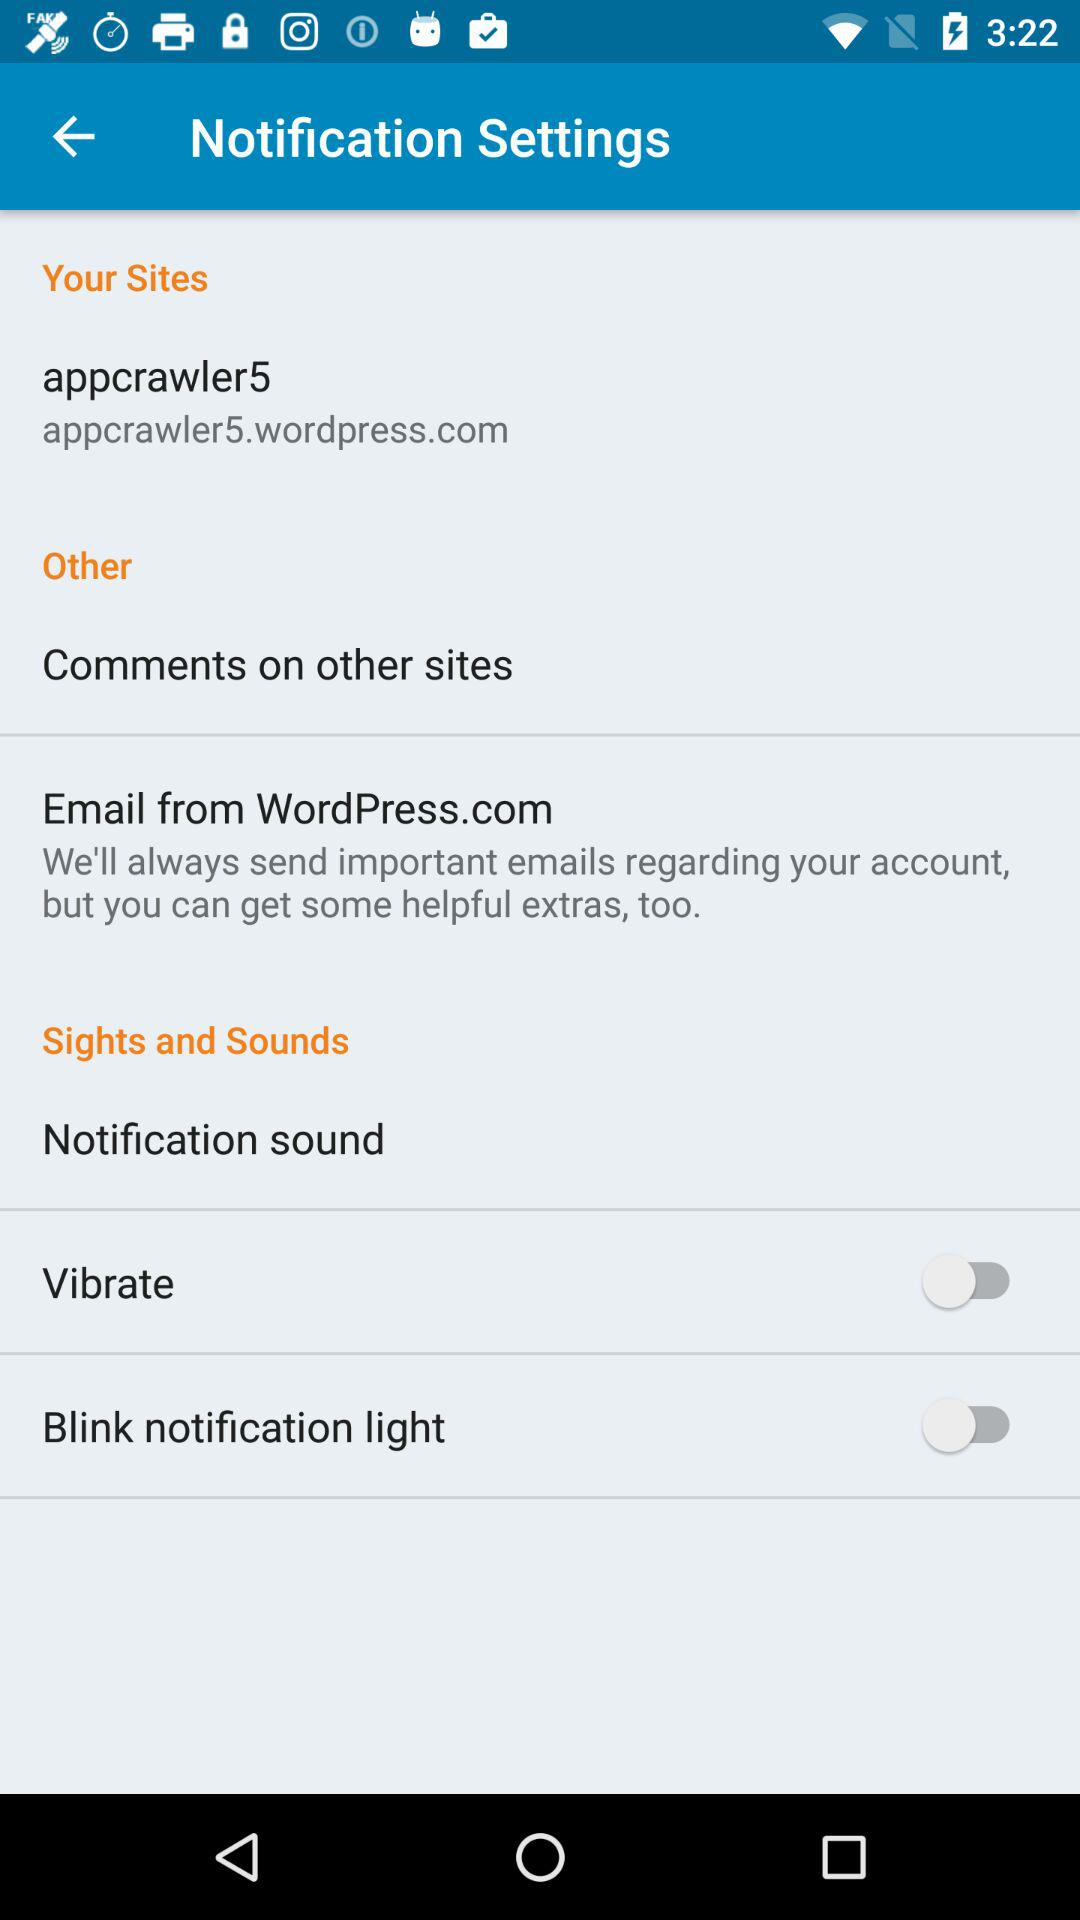What is the name of the website? The name of the website is "appcrawler5.wordpress.com". 